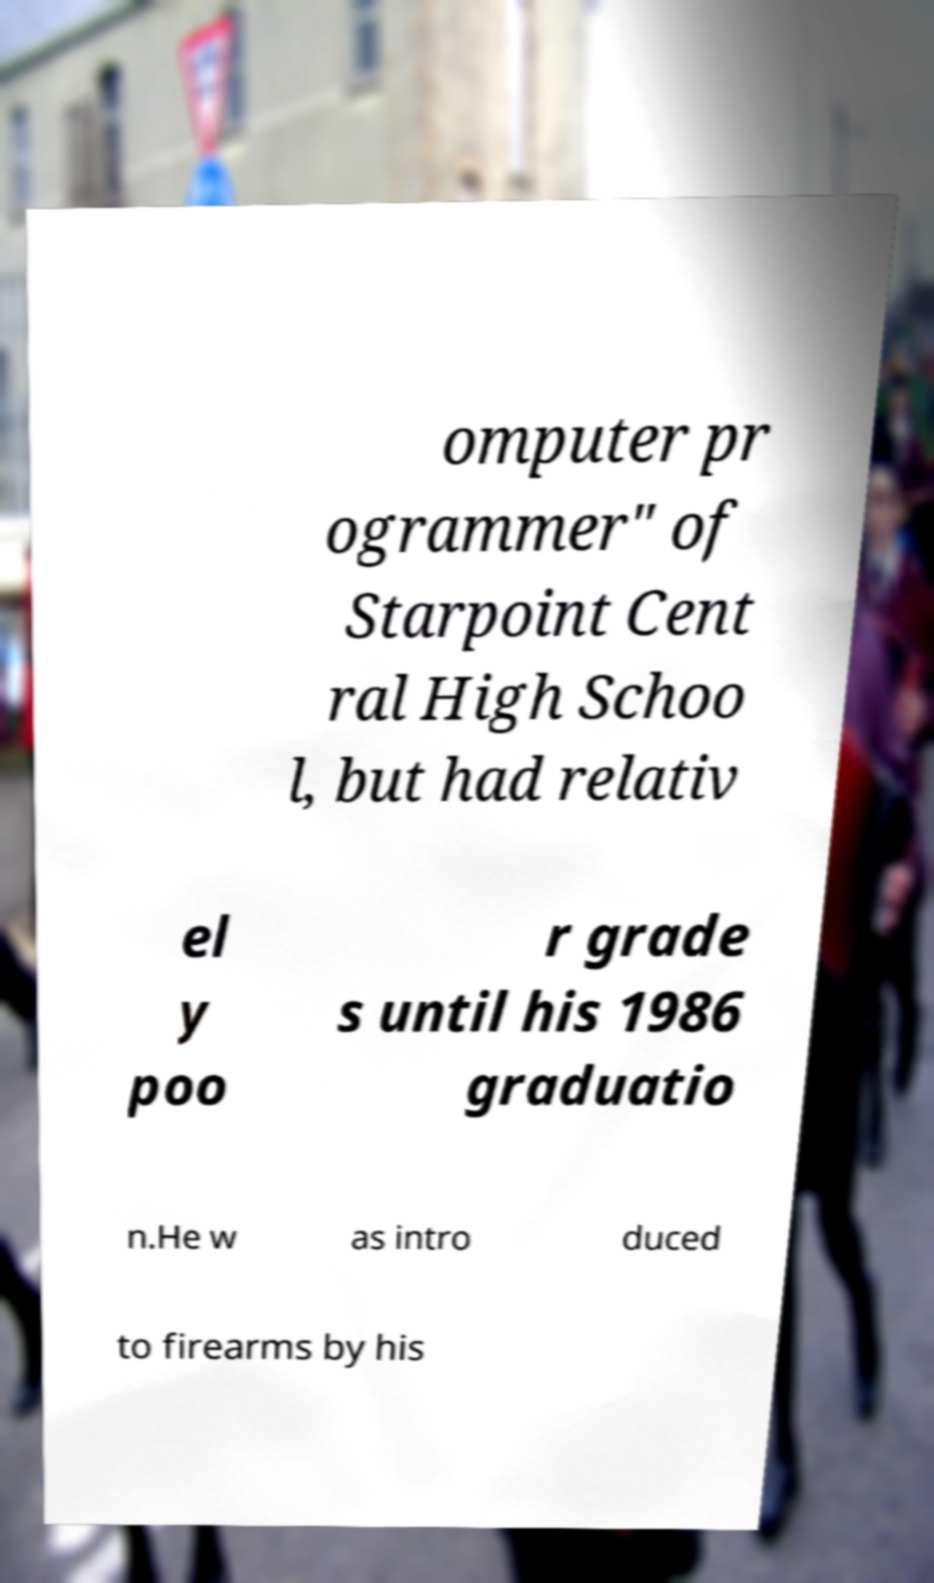For documentation purposes, I need the text within this image transcribed. Could you provide that? omputer pr ogrammer" of Starpoint Cent ral High Schoo l, but had relativ el y poo r grade s until his 1986 graduatio n.He w as intro duced to firearms by his 